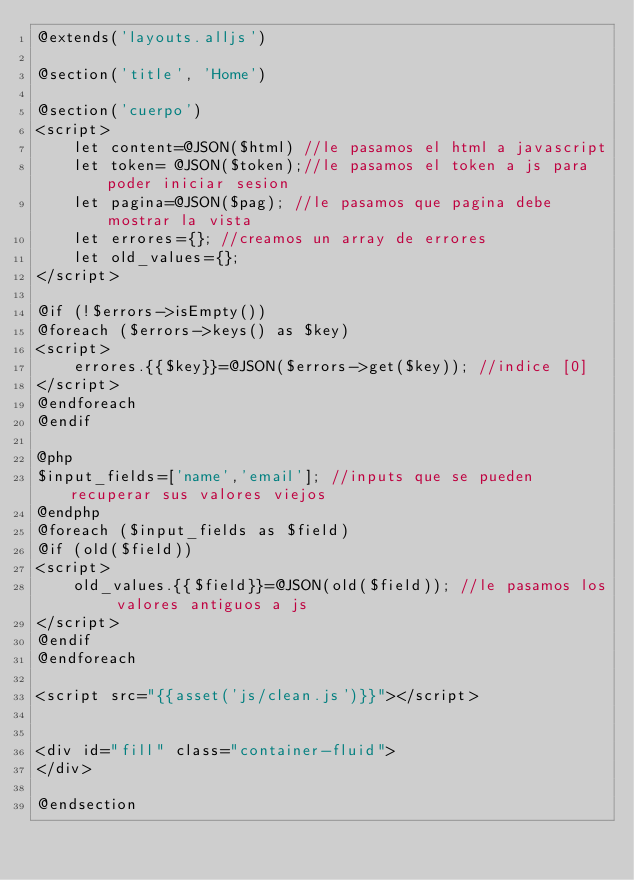<code> <loc_0><loc_0><loc_500><loc_500><_PHP_>@extends('layouts.alljs')

@section('title', 'Home')

@section('cuerpo')
<script>
    let content=@JSON($html) //le pasamos el html a javascript
    let token= @JSON($token);//le pasamos el token a js para poder iniciar sesion
    let pagina=@JSON($pag); //le pasamos que pagina debe mostrar la vista
    let errores={}; //creamos un array de errores
    let old_values={};
</script>

@if (!$errors->isEmpty())
@foreach ($errors->keys() as $key)
<script>
    errores.{{$key}}=@JSON($errors->get($key)); //indice [0]
</script>
@endforeach
@endif

@php
$input_fields=['name','email']; //inputs que se pueden recuperar sus valores viejos
@endphp
@foreach ($input_fields as $field)
@if (old($field))
<script>
    old_values.{{$field}}=@JSON(old($field)); //le pasamos los valores antiguos a js
</script>
@endif
@endforeach

<script src="{{asset('js/clean.js')}}"></script>


<div id="fill" class="container-fluid">
</div>

@endsection</code> 